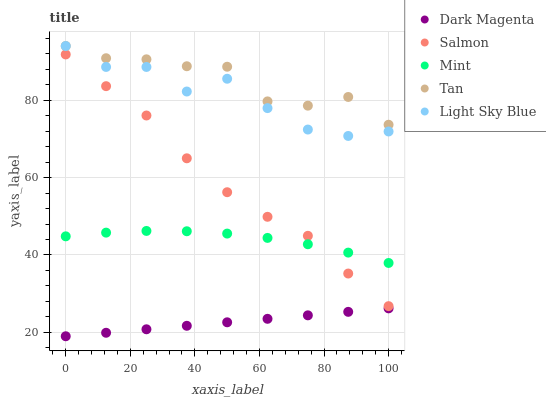Does Dark Magenta have the minimum area under the curve?
Answer yes or no. Yes. Does Tan have the maximum area under the curve?
Answer yes or no. Yes. Does Light Sky Blue have the minimum area under the curve?
Answer yes or no. No. Does Light Sky Blue have the maximum area under the curve?
Answer yes or no. No. Is Dark Magenta the smoothest?
Answer yes or no. Yes. Is Light Sky Blue the roughest?
Answer yes or no. Yes. Is Tan the smoothest?
Answer yes or no. No. Is Tan the roughest?
Answer yes or no. No. Does Dark Magenta have the lowest value?
Answer yes or no. Yes. Does Light Sky Blue have the lowest value?
Answer yes or no. No. Does Light Sky Blue have the highest value?
Answer yes or no. Yes. Does Salmon have the highest value?
Answer yes or no. No. Is Dark Magenta less than Tan?
Answer yes or no. Yes. Is Light Sky Blue greater than Salmon?
Answer yes or no. Yes. Does Mint intersect Salmon?
Answer yes or no. Yes. Is Mint less than Salmon?
Answer yes or no. No. Is Mint greater than Salmon?
Answer yes or no. No. Does Dark Magenta intersect Tan?
Answer yes or no. No. 